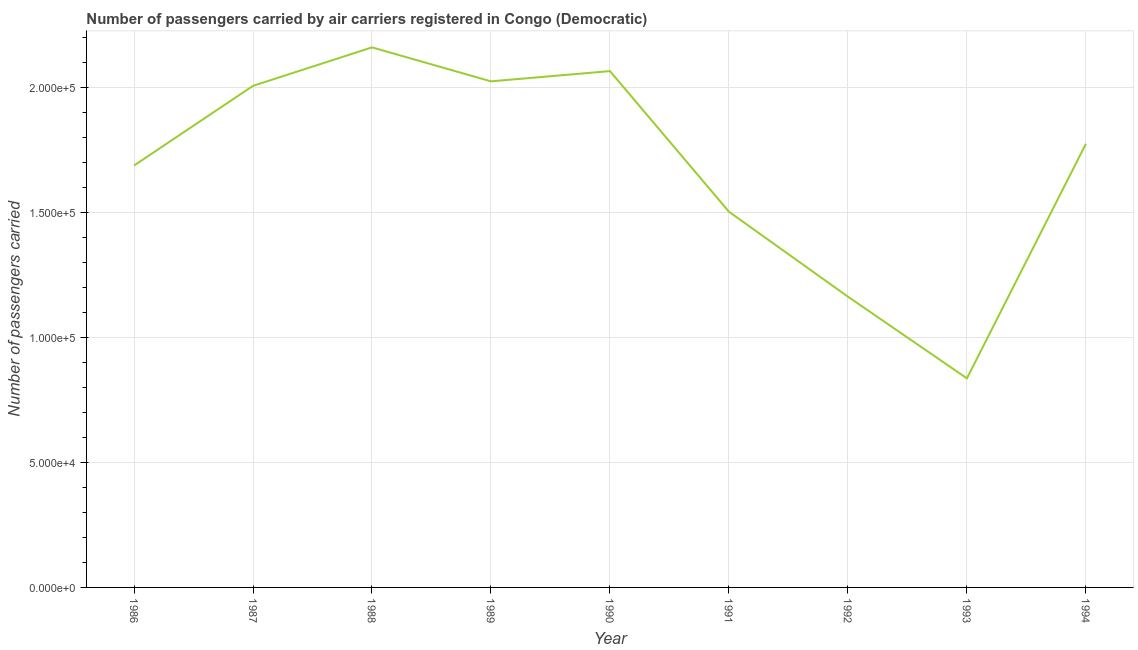What is the number of passengers carried in 1994?
Your response must be concise. 1.78e+05. Across all years, what is the maximum number of passengers carried?
Offer a terse response. 2.16e+05. Across all years, what is the minimum number of passengers carried?
Your answer should be compact. 8.37e+04. In which year was the number of passengers carried maximum?
Provide a short and direct response. 1988. In which year was the number of passengers carried minimum?
Your answer should be very brief. 1993. What is the sum of the number of passengers carried?
Provide a short and direct response. 1.52e+06. What is the difference between the number of passengers carried in 1990 and 1992?
Offer a very short reply. 9.03e+04. What is the average number of passengers carried per year?
Your response must be concise. 1.69e+05. What is the median number of passengers carried?
Your answer should be compact. 1.78e+05. Do a majority of the years between 1993 and 1991 (inclusive) have number of passengers carried greater than 70000 ?
Provide a succinct answer. No. What is the ratio of the number of passengers carried in 1987 to that in 1988?
Keep it short and to the point. 0.93. Is the number of passengers carried in 1986 less than that in 1994?
Your answer should be compact. Yes. What is the difference between the highest and the second highest number of passengers carried?
Make the answer very short. 9500. What is the difference between the highest and the lowest number of passengers carried?
Make the answer very short. 1.32e+05. Does the number of passengers carried monotonically increase over the years?
Offer a very short reply. No. How many years are there in the graph?
Your answer should be compact. 9. What is the difference between two consecutive major ticks on the Y-axis?
Offer a very short reply. 5.00e+04. Are the values on the major ticks of Y-axis written in scientific E-notation?
Offer a very short reply. Yes. What is the title of the graph?
Offer a very short reply. Number of passengers carried by air carriers registered in Congo (Democratic). What is the label or title of the Y-axis?
Offer a very short reply. Number of passengers carried. What is the Number of passengers carried of 1986?
Your answer should be compact. 1.69e+05. What is the Number of passengers carried of 1987?
Offer a terse response. 2.01e+05. What is the Number of passengers carried of 1988?
Offer a very short reply. 2.16e+05. What is the Number of passengers carried in 1989?
Your answer should be very brief. 2.03e+05. What is the Number of passengers carried in 1990?
Provide a succinct answer. 2.07e+05. What is the Number of passengers carried of 1991?
Offer a terse response. 1.50e+05. What is the Number of passengers carried of 1992?
Ensure brevity in your answer.  1.16e+05. What is the Number of passengers carried of 1993?
Your answer should be very brief. 8.37e+04. What is the Number of passengers carried of 1994?
Provide a succinct answer. 1.78e+05. What is the difference between the Number of passengers carried in 1986 and 1987?
Offer a very short reply. -3.19e+04. What is the difference between the Number of passengers carried in 1986 and 1988?
Provide a succinct answer. -4.73e+04. What is the difference between the Number of passengers carried in 1986 and 1989?
Offer a terse response. -3.37e+04. What is the difference between the Number of passengers carried in 1986 and 1990?
Offer a very short reply. -3.78e+04. What is the difference between the Number of passengers carried in 1986 and 1991?
Provide a succinct answer. 1.85e+04. What is the difference between the Number of passengers carried in 1986 and 1992?
Offer a very short reply. 5.25e+04. What is the difference between the Number of passengers carried in 1986 and 1993?
Provide a succinct answer. 8.52e+04. What is the difference between the Number of passengers carried in 1986 and 1994?
Your answer should be very brief. -8700. What is the difference between the Number of passengers carried in 1987 and 1988?
Your answer should be compact. -1.54e+04. What is the difference between the Number of passengers carried in 1987 and 1989?
Ensure brevity in your answer.  -1800. What is the difference between the Number of passengers carried in 1987 and 1990?
Your answer should be very brief. -5900. What is the difference between the Number of passengers carried in 1987 and 1991?
Keep it short and to the point. 5.04e+04. What is the difference between the Number of passengers carried in 1987 and 1992?
Provide a succinct answer. 8.44e+04. What is the difference between the Number of passengers carried in 1987 and 1993?
Provide a succinct answer. 1.17e+05. What is the difference between the Number of passengers carried in 1987 and 1994?
Ensure brevity in your answer.  2.32e+04. What is the difference between the Number of passengers carried in 1988 and 1989?
Provide a short and direct response. 1.36e+04. What is the difference between the Number of passengers carried in 1988 and 1990?
Provide a short and direct response. 9500. What is the difference between the Number of passengers carried in 1988 and 1991?
Make the answer very short. 6.58e+04. What is the difference between the Number of passengers carried in 1988 and 1992?
Provide a short and direct response. 9.98e+04. What is the difference between the Number of passengers carried in 1988 and 1993?
Provide a succinct answer. 1.32e+05. What is the difference between the Number of passengers carried in 1988 and 1994?
Provide a short and direct response. 3.86e+04. What is the difference between the Number of passengers carried in 1989 and 1990?
Offer a very short reply. -4100. What is the difference between the Number of passengers carried in 1989 and 1991?
Make the answer very short. 5.22e+04. What is the difference between the Number of passengers carried in 1989 and 1992?
Keep it short and to the point. 8.62e+04. What is the difference between the Number of passengers carried in 1989 and 1993?
Offer a terse response. 1.19e+05. What is the difference between the Number of passengers carried in 1989 and 1994?
Keep it short and to the point. 2.50e+04. What is the difference between the Number of passengers carried in 1990 and 1991?
Your response must be concise. 5.63e+04. What is the difference between the Number of passengers carried in 1990 and 1992?
Make the answer very short. 9.03e+04. What is the difference between the Number of passengers carried in 1990 and 1993?
Keep it short and to the point. 1.23e+05. What is the difference between the Number of passengers carried in 1990 and 1994?
Provide a succinct answer. 2.91e+04. What is the difference between the Number of passengers carried in 1991 and 1992?
Provide a succinct answer. 3.40e+04. What is the difference between the Number of passengers carried in 1991 and 1993?
Your answer should be compact. 6.67e+04. What is the difference between the Number of passengers carried in 1991 and 1994?
Ensure brevity in your answer.  -2.72e+04. What is the difference between the Number of passengers carried in 1992 and 1993?
Give a very brief answer. 3.27e+04. What is the difference between the Number of passengers carried in 1992 and 1994?
Your response must be concise. -6.12e+04. What is the difference between the Number of passengers carried in 1993 and 1994?
Your response must be concise. -9.39e+04. What is the ratio of the Number of passengers carried in 1986 to that in 1987?
Provide a short and direct response. 0.84. What is the ratio of the Number of passengers carried in 1986 to that in 1988?
Give a very brief answer. 0.78. What is the ratio of the Number of passengers carried in 1986 to that in 1989?
Offer a terse response. 0.83. What is the ratio of the Number of passengers carried in 1986 to that in 1990?
Offer a very short reply. 0.82. What is the ratio of the Number of passengers carried in 1986 to that in 1991?
Provide a succinct answer. 1.12. What is the ratio of the Number of passengers carried in 1986 to that in 1992?
Keep it short and to the point. 1.45. What is the ratio of the Number of passengers carried in 1986 to that in 1993?
Offer a very short reply. 2.02. What is the ratio of the Number of passengers carried in 1986 to that in 1994?
Offer a terse response. 0.95. What is the ratio of the Number of passengers carried in 1987 to that in 1988?
Provide a succinct answer. 0.93. What is the ratio of the Number of passengers carried in 1987 to that in 1990?
Make the answer very short. 0.97. What is the ratio of the Number of passengers carried in 1987 to that in 1991?
Offer a very short reply. 1.33. What is the ratio of the Number of passengers carried in 1987 to that in 1992?
Provide a short and direct response. 1.73. What is the ratio of the Number of passengers carried in 1987 to that in 1993?
Make the answer very short. 2.4. What is the ratio of the Number of passengers carried in 1987 to that in 1994?
Provide a succinct answer. 1.13. What is the ratio of the Number of passengers carried in 1988 to that in 1989?
Your response must be concise. 1.07. What is the ratio of the Number of passengers carried in 1988 to that in 1990?
Offer a terse response. 1.05. What is the ratio of the Number of passengers carried in 1988 to that in 1991?
Keep it short and to the point. 1.44. What is the ratio of the Number of passengers carried in 1988 to that in 1992?
Your response must be concise. 1.86. What is the ratio of the Number of passengers carried in 1988 to that in 1993?
Your answer should be very brief. 2.58. What is the ratio of the Number of passengers carried in 1988 to that in 1994?
Offer a terse response. 1.22. What is the ratio of the Number of passengers carried in 1989 to that in 1991?
Provide a succinct answer. 1.35. What is the ratio of the Number of passengers carried in 1989 to that in 1992?
Provide a short and direct response. 1.74. What is the ratio of the Number of passengers carried in 1989 to that in 1993?
Offer a very short reply. 2.42. What is the ratio of the Number of passengers carried in 1989 to that in 1994?
Ensure brevity in your answer.  1.14. What is the ratio of the Number of passengers carried in 1990 to that in 1991?
Your answer should be compact. 1.37. What is the ratio of the Number of passengers carried in 1990 to that in 1992?
Provide a short and direct response. 1.78. What is the ratio of the Number of passengers carried in 1990 to that in 1993?
Make the answer very short. 2.47. What is the ratio of the Number of passengers carried in 1990 to that in 1994?
Give a very brief answer. 1.16. What is the ratio of the Number of passengers carried in 1991 to that in 1992?
Your response must be concise. 1.29. What is the ratio of the Number of passengers carried in 1991 to that in 1993?
Provide a short and direct response. 1.8. What is the ratio of the Number of passengers carried in 1991 to that in 1994?
Ensure brevity in your answer.  0.85. What is the ratio of the Number of passengers carried in 1992 to that in 1993?
Your answer should be compact. 1.39. What is the ratio of the Number of passengers carried in 1992 to that in 1994?
Your answer should be very brief. 0.66. What is the ratio of the Number of passengers carried in 1993 to that in 1994?
Ensure brevity in your answer.  0.47. 